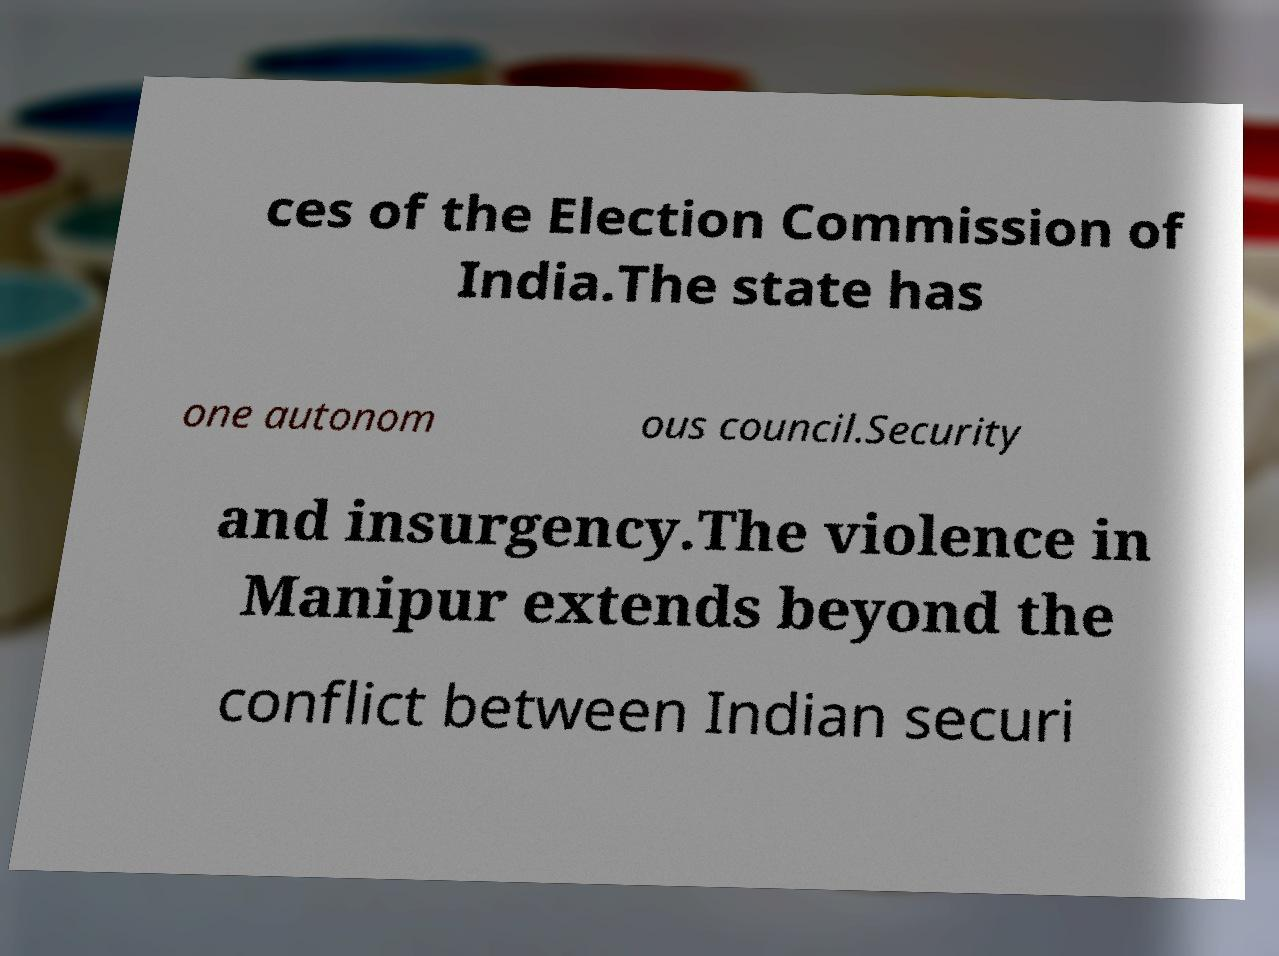Please identify and transcribe the text found in this image. ces of the Election Commission of India.The state has one autonom ous council.Security and insurgency.The violence in Manipur extends beyond the conflict between Indian securi 